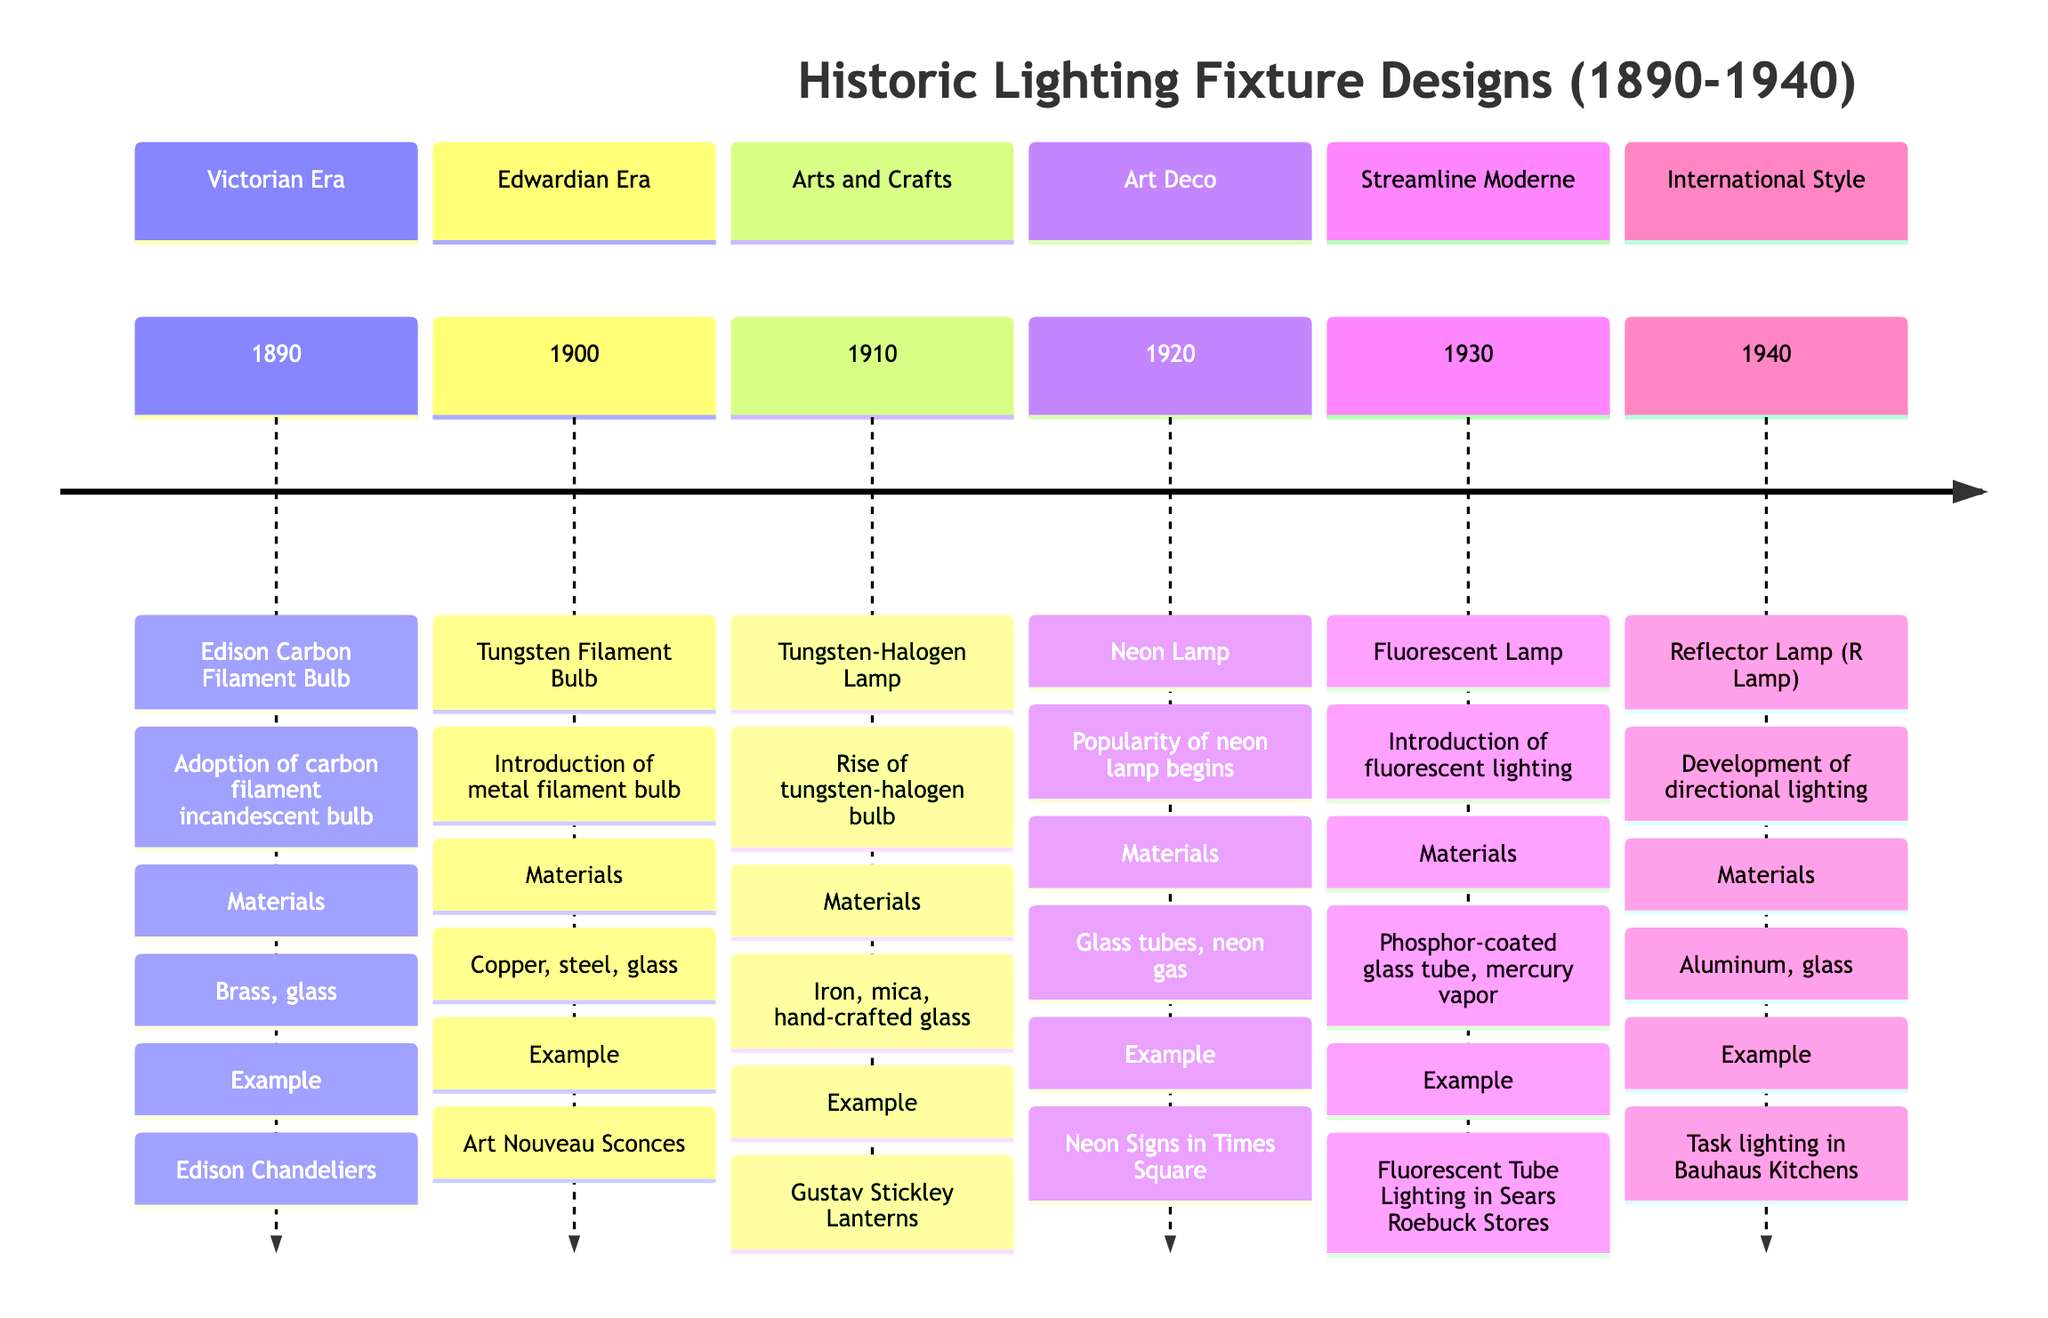What lighting fixture was adopted in 1890? The timeline indicates that the lighting fixture adopted in 1890 was the Edison Carbon Filament Bulb.
Answer: Edison Carbon Filament Bulb Which architectural era corresponds to the Neon Lamp introduction? According to the timeline, the Neon Lamp was introduced during the Art Deco architectural era.
Answer: Art Deco How many notable examples are listed for the Tungsten Filament Bulb? The timeline specifies one notable example for the Tungsten Filament Bulb, which is the Art Nouveau Sconces.
Answer: 1 What materials were used for the Reflector Lamp? For the Reflector Lamp, the timeline states that the materials used were aluminum and glass.
Answer: Aluminum, glass In which year did the introduction of fluorescent lighting occur? The timeline shows that the introduction of fluorescent lighting occurred in the year 1930.
Answer: 1930 What significant advancement occurred in 1910? The timeline notes that the significant advancement in 1910 was the rise of the tungsten-halogen bulb, increasing efficiency and brightness.
Answer: Rise of tungsten-halogen bulb What is the notable example associated with the Edison Carbon Filament Bulb? The timeline provides that the notable example associated with the Edison Carbon Filament Bulb is the Edison Chandeliers.
Answer: Edison Chandeliers What dual materials were used for the Tungsten-Halogen Lamp? According to the timeline, the Tungsten-Halogen Lamp was made from iron, mica, and hand-crafted glass. The dual materials answer will focus on iron and glass.
Answer: Iron, glass Which lighting fixture began the popularity of neon lamps? The timeline indicates that the Neon Lamp began the popularity of neon lamps around 1920.
Answer: Neon Lamp 